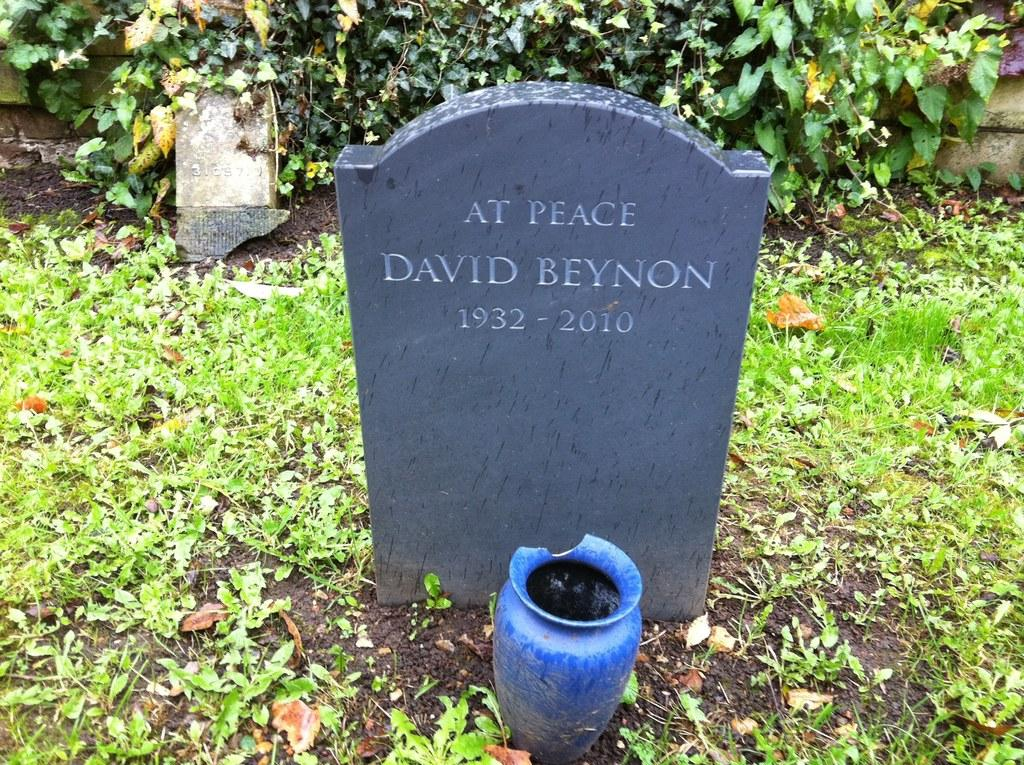What is the main subject of the image? The image depicts a graveyard. Are there any other elements visible in the image besides the graveyard? Yes, there are plants visible behind the graveyard. What type of sweater is the letter wearing in the image? There is no sweater or letter present in the image; it depicts a graveyard and plants. 